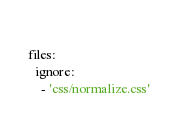Convert code to text. <code><loc_0><loc_0><loc_500><loc_500><_YAML_>    
files: 
  ignore:
    - 'css/normalize.css'</code> 